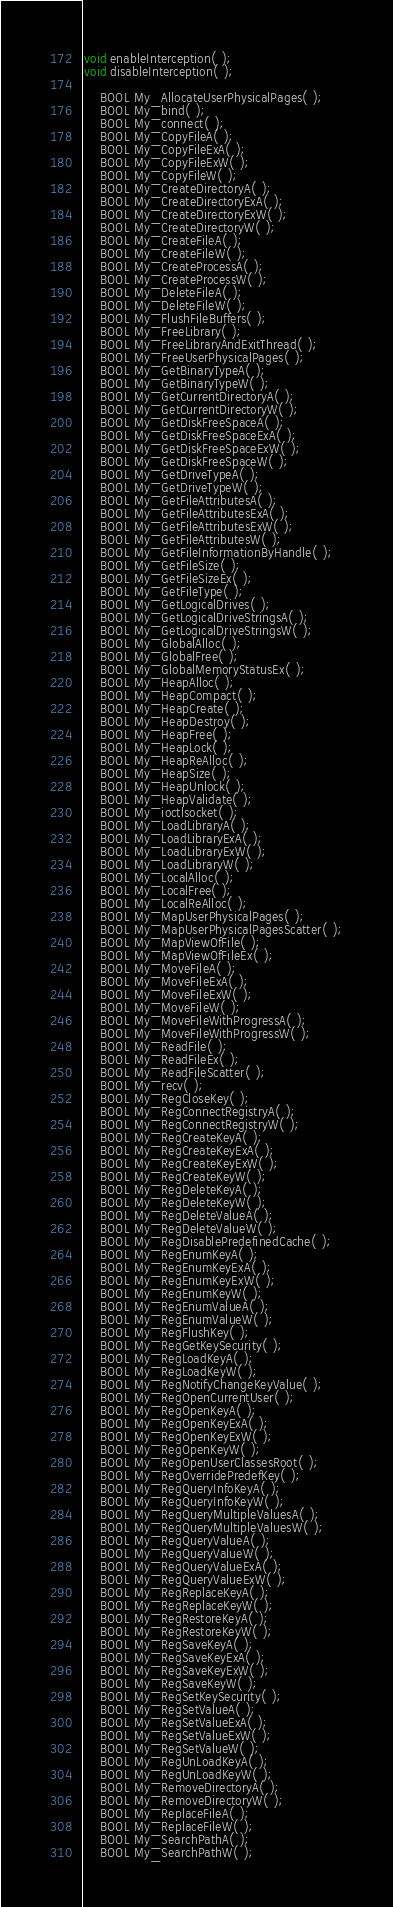<code> <loc_0><loc_0><loc_500><loc_500><_C_>void enableInterception( );
void disableInterception( );

    BOOL My_AllocateUserPhysicalPages( );
    BOOL My_bind( );
    BOOL My_connect( );
    BOOL My_CopyFileA( );
    BOOL My_CopyFileExA( );
    BOOL My_CopyFileExW( );
    BOOL My_CopyFileW( );
    BOOL My_CreateDirectoryA( );
    BOOL My_CreateDirectoryExA( );
    BOOL My_CreateDirectoryExW( );
    BOOL My_CreateDirectoryW( );
    BOOL My_CreateFileA( );
    BOOL My_CreateFileW( );
    BOOL My_CreateProcessA( );
    BOOL My_CreateProcessW( );
    BOOL My_DeleteFileA( );
    BOOL My_DeleteFileW( );
    BOOL My_FlushFileBuffers( );
    BOOL My_FreeLibrary( );
    BOOL My_FreeLibraryAndExitThread( );
    BOOL My_FreeUserPhysicalPages( );
    BOOL My_GetBinaryTypeA( );
    BOOL My_GetBinaryTypeW( );
    BOOL My_GetCurrentDirectoryA( );
    BOOL My_GetCurrentDirectoryW( );
    BOOL My_GetDiskFreeSpaceA( );
    BOOL My_GetDiskFreeSpaceExA( );
    BOOL My_GetDiskFreeSpaceExW( );
    BOOL My_GetDiskFreeSpaceW( );
    BOOL My_GetDriveTypeA( );
    BOOL My_GetDriveTypeW( );
    BOOL My_GetFileAttributesA( );
    BOOL My_GetFileAttributesExA( );
    BOOL My_GetFileAttributesExW( );
    BOOL My_GetFileAttributesW( );
    BOOL My_GetFileInformationByHandle( );
    BOOL My_GetFileSize( );
    BOOL My_GetFileSizeEx( );
    BOOL My_GetFileType( );
    BOOL My_GetLogicalDrives( );
    BOOL My_GetLogicalDriveStringsA( );
    BOOL My_GetLogicalDriveStringsW( );
    BOOL My_GlobalAlloc( );
    BOOL My_GlobalFree( );
    BOOL My_GlobalMemoryStatusEx( );
    BOOL My_HeapAlloc( );
    BOOL My_HeapCompact( );
    BOOL My_HeapCreate( );
    BOOL My_HeapDestroy( );
    BOOL My_HeapFree( );
    BOOL My_HeapLock( );
    BOOL My_HeapReAlloc( );
    BOOL My_HeapSize( );
    BOOL My_HeapUnlock( );
    BOOL My_HeapValidate( );
    BOOL My_ioctlsocket( );
    BOOL My_LoadLibraryA( );
    BOOL My_LoadLibraryExA( );
    BOOL My_LoadLibraryExW( );
    BOOL My_LoadLibraryW( );
    BOOL My_LocalAlloc( );
    BOOL My_LocalFree( );
    BOOL My_LocalReAlloc( );
    BOOL My_MapUserPhysicalPages( );
    BOOL My_MapUserPhysicalPagesScatter( );
    BOOL My_MapViewOfFile( );
    BOOL My_MapViewOfFileEx( );
    BOOL My_MoveFileA( );
    BOOL My_MoveFileExA( );
    BOOL My_MoveFileExW( );
    BOOL My_MoveFileW( );
    BOOL My_MoveFileWithProgressA( );
    BOOL My_MoveFileWithProgressW( );
    BOOL My_ReadFile( );
    BOOL My_ReadFileEx( );
    BOOL My_ReadFileScatter( );
    BOOL My_recv( );
    BOOL My_RegCloseKey( );
    BOOL My_RegConnectRegistryA( );
    BOOL My_RegConnectRegistryW( );
    BOOL My_RegCreateKeyA( );
    BOOL My_RegCreateKeyExA( );
    BOOL My_RegCreateKeyExW( );
    BOOL My_RegCreateKeyW( );
    BOOL My_RegDeleteKeyA( );
    BOOL My_RegDeleteKeyW( );
    BOOL My_RegDeleteValueA( );
    BOOL My_RegDeleteValueW( );
    BOOL My_RegDisablePredefinedCache( );
    BOOL My_RegEnumKeyA( );
    BOOL My_RegEnumKeyExA( );
    BOOL My_RegEnumKeyExW( );
    BOOL My_RegEnumKeyW( );
    BOOL My_RegEnumValueA( );
    BOOL My_RegEnumValueW( );
    BOOL My_RegFlushKey( );
    BOOL My_RegGetKeySecurity( );
    BOOL My_RegLoadKeyA( );
    BOOL My_RegLoadKeyW( );
    BOOL My_RegNotifyChangeKeyValue( );
    BOOL My_RegOpenCurrentUser( );
    BOOL My_RegOpenKeyA( );
    BOOL My_RegOpenKeyExA( );
    BOOL My_RegOpenKeyExW( );
    BOOL My_RegOpenKeyW( );
    BOOL My_RegOpenUserClassesRoot( );
    BOOL My_RegOverridePredefKey( );
    BOOL My_RegQueryInfoKeyA( );
    BOOL My_RegQueryInfoKeyW( );
    BOOL My_RegQueryMultipleValuesA( );
    BOOL My_RegQueryMultipleValuesW( );
    BOOL My_RegQueryValueA( );
    BOOL My_RegQueryValueW( );
    BOOL My_RegQueryValueExA( );
    BOOL My_RegQueryValueExW( );
    BOOL My_RegReplaceKeyA( );
    BOOL My_RegReplaceKeyW( );
    BOOL My_RegRestoreKeyA( );
    BOOL My_RegRestoreKeyW( );
    BOOL My_RegSaveKeyA( );
    BOOL My_RegSaveKeyExA( );
    BOOL My_RegSaveKeyExW( );
    BOOL My_RegSaveKeyW( );
    BOOL My_RegSetKeySecurity( );
    BOOL My_RegSetValueA( );
    BOOL My_RegSetValueExA( );
    BOOL My_RegSetValueExW( );
    BOOL My_RegSetValueW( );
    BOOL My_RegUnLoadKeyA( );
    BOOL My_RegUnLoadKeyW( );
    BOOL My_RemoveDirectoryA( );
    BOOL My_RemoveDirectoryW( );
    BOOL My_ReplaceFileA( );
    BOOL My_ReplaceFileW( );
    BOOL My_SearchPathA( );
    BOOL My_SearchPathW( );</code> 